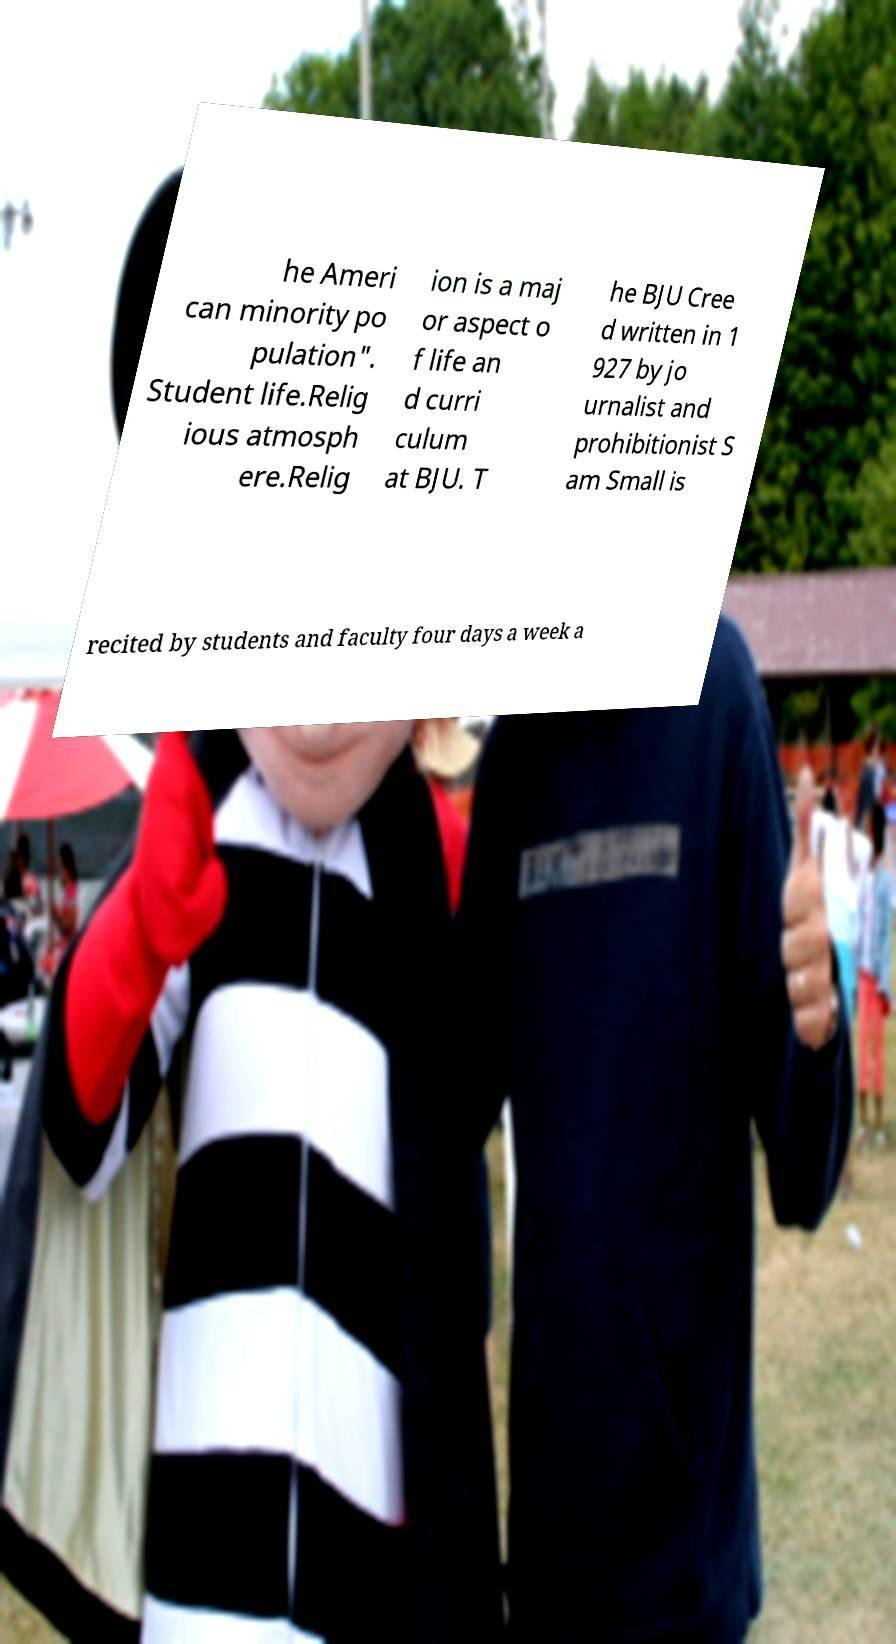There's text embedded in this image that I need extracted. Can you transcribe it verbatim? he Ameri can minority po pulation". Student life.Relig ious atmosph ere.Relig ion is a maj or aspect o f life an d curri culum at BJU. T he BJU Cree d written in 1 927 by jo urnalist and prohibitionist S am Small is recited by students and faculty four days a week a 